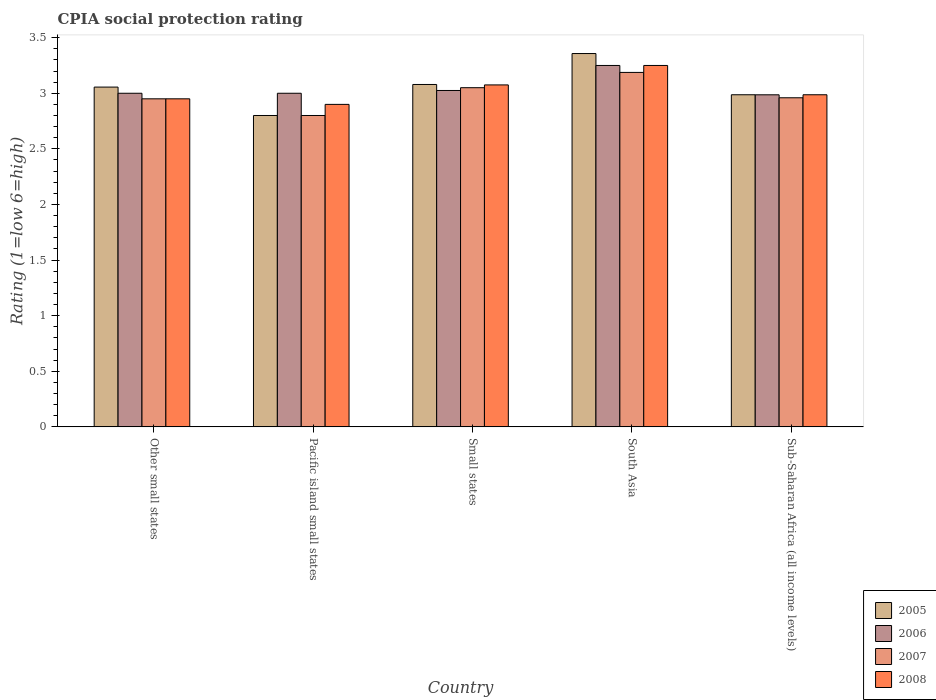How many groups of bars are there?
Your answer should be compact. 5. Are the number of bars per tick equal to the number of legend labels?
Your answer should be compact. Yes. How many bars are there on the 1st tick from the left?
Offer a very short reply. 4. How many bars are there on the 5th tick from the right?
Offer a terse response. 4. What is the label of the 4th group of bars from the left?
Provide a short and direct response. South Asia. What is the CPIA rating in 2005 in Sub-Saharan Africa (all income levels)?
Your answer should be compact. 2.99. Across all countries, what is the maximum CPIA rating in 2006?
Keep it short and to the point. 3.25. Across all countries, what is the minimum CPIA rating in 2006?
Provide a short and direct response. 2.99. In which country was the CPIA rating in 2007 maximum?
Offer a terse response. South Asia. In which country was the CPIA rating in 2008 minimum?
Your answer should be very brief. Pacific island small states. What is the total CPIA rating in 2007 in the graph?
Keep it short and to the point. 14.95. What is the difference between the CPIA rating in 2007 in Other small states and that in South Asia?
Provide a succinct answer. -0.24. What is the difference between the CPIA rating in 2006 in Sub-Saharan Africa (all income levels) and the CPIA rating in 2005 in Other small states?
Make the answer very short. -0.07. What is the average CPIA rating in 2005 per country?
Provide a succinct answer. 3.06. What is the difference between the CPIA rating of/in 2007 and CPIA rating of/in 2005 in South Asia?
Provide a short and direct response. -0.17. What is the ratio of the CPIA rating in 2008 in Other small states to that in Small states?
Your answer should be very brief. 0.96. What is the difference between the highest and the second highest CPIA rating in 2005?
Your answer should be compact. -0.28. What is the difference between the highest and the lowest CPIA rating in 2006?
Provide a succinct answer. 0.26. In how many countries, is the CPIA rating in 2006 greater than the average CPIA rating in 2006 taken over all countries?
Provide a succinct answer. 1. Is the sum of the CPIA rating in 2007 in Small states and South Asia greater than the maximum CPIA rating in 2005 across all countries?
Provide a short and direct response. Yes. Is it the case that in every country, the sum of the CPIA rating in 2005 and CPIA rating in 2008 is greater than the sum of CPIA rating in 2006 and CPIA rating in 2007?
Offer a terse response. No. What does the 3rd bar from the right in Small states represents?
Give a very brief answer. 2006. Are all the bars in the graph horizontal?
Make the answer very short. No. How many countries are there in the graph?
Ensure brevity in your answer.  5. What is the difference between two consecutive major ticks on the Y-axis?
Your answer should be very brief. 0.5. Does the graph contain any zero values?
Provide a succinct answer. No. Does the graph contain grids?
Provide a succinct answer. No. What is the title of the graph?
Your response must be concise. CPIA social protection rating. Does "1973" appear as one of the legend labels in the graph?
Provide a short and direct response. No. What is the label or title of the X-axis?
Ensure brevity in your answer.  Country. What is the Rating (1=low 6=high) of 2005 in Other small states?
Your response must be concise. 3.06. What is the Rating (1=low 6=high) of 2007 in Other small states?
Your answer should be very brief. 2.95. What is the Rating (1=low 6=high) in 2008 in Other small states?
Your response must be concise. 2.95. What is the Rating (1=low 6=high) in 2005 in Pacific island small states?
Give a very brief answer. 2.8. What is the Rating (1=low 6=high) of 2006 in Pacific island small states?
Ensure brevity in your answer.  3. What is the Rating (1=low 6=high) in 2008 in Pacific island small states?
Give a very brief answer. 2.9. What is the Rating (1=low 6=high) in 2005 in Small states?
Make the answer very short. 3.08. What is the Rating (1=low 6=high) in 2006 in Small states?
Make the answer very short. 3.02. What is the Rating (1=low 6=high) of 2007 in Small states?
Ensure brevity in your answer.  3.05. What is the Rating (1=low 6=high) of 2008 in Small states?
Provide a short and direct response. 3.08. What is the Rating (1=low 6=high) of 2005 in South Asia?
Provide a short and direct response. 3.36. What is the Rating (1=low 6=high) in 2006 in South Asia?
Your answer should be very brief. 3.25. What is the Rating (1=low 6=high) of 2007 in South Asia?
Make the answer very short. 3.19. What is the Rating (1=low 6=high) in 2008 in South Asia?
Offer a terse response. 3.25. What is the Rating (1=low 6=high) in 2005 in Sub-Saharan Africa (all income levels)?
Ensure brevity in your answer.  2.99. What is the Rating (1=low 6=high) in 2006 in Sub-Saharan Africa (all income levels)?
Offer a very short reply. 2.99. What is the Rating (1=low 6=high) in 2007 in Sub-Saharan Africa (all income levels)?
Your answer should be very brief. 2.96. What is the Rating (1=low 6=high) in 2008 in Sub-Saharan Africa (all income levels)?
Offer a terse response. 2.99. Across all countries, what is the maximum Rating (1=low 6=high) of 2005?
Your answer should be compact. 3.36. Across all countries, what is the maximum Rating (1=low 6=high) in 2006?
Your answer should be compact. 3.25. Across all countries, what is the maximum Rating (1=low 6=high) of 2007?
Keep it short and to the point. 3.19. Across all countries, what is the minimum Rating (1=low 6=high) of 2005?
Your response must be concise. 2.8. Across all countries, what is the minimum Rating (1=low 6=high) in 2006?
Your response must be concise. 2.99. Across all countries, what is the minimum Rating (1=low 6=high) in 2007?
Provide a short and direct response. 2.8. Across all countries, what is the minimum Rating (1=low 6=high) in 2008?
Your response must be concise. 2.9. What is the total Rating (1=low 6=high) of 2005 in the graph?
Give a very brief answer. 15.28. What is the total Rating (1=low 6=high) in 2006 in the graph?
Keep it short and to the point. 15.26. What is the total Rating (1=low 6=high) of 2007 in the graph?
Your answer should be very brief. 14.95. What is the total Rating (1=low 6=high) in 2008 in the graph?
Ensure brevity in your answer.  15.16. What is the difference between the Rating (1=low 6=high) in 2005 in Other small states and that in Pacific island small states?
Offer a very short reply. 0.26. What is the difference between the Rating (1=low 6=high) of 2007 in Other small states and that in Pacific island small states?
Give a very brief answer. 0.15. What is the difference between the Rating (1=low 6=high) of 2005 in Other small states and that in Small states?
Provide a succinct answer. -0.02. What is the difference between the Rating (1=low 6=high) in 2006 in Other small states and that in Small states?
Your answer should be compact. -0.03. What is the difference between the Rating (1=low 6=high) in 2008 in Other small states and that in Small states?
Offer a very short reply. -0.12. What is the difference between the Rating (1=low 6=high) in 2005 in Other small states and that in South Asia?
Your answer should be compact. -0.3. What is the difference between the Rating (1=low 6=high) of 2006 in Other small states and that in South Asia?
Keep it short and to the point. -0.25. What is the difference between the Rating (1=low 6=high) in 2007 in Other small states and that in South Asia?
Provide a succinct answer. -0.24. What is the difference between the Rating (1=low 6=high) of 2008 in Other small states and that in South Asia?
Give a very brief answer. -0.3. What is the difference between the Rating (1=low 6=high) of 2005 in Other small states and that in Sub-Saharan Africa (all income levels)?
Your answer should be very brief. 0.07. What is the difference between the Rating (1=low 6=high) in 2006 in Other small states and that in Sub-Saharan Africa (all income levels)?
Provide a succinct answer. 0.01. What is the difference between the Rating (1=low 6=high) of 2007 in Other small states and that in Sub-Saharan Africa (all income levels)?
Offer a very short reply. -0.01. What is the difference between the Rating (1=low 6=high) in 2008 in Other small states and that in Sub-Saharan Africa (all income levels)?
Your response must be concise. -0.04. What is the difference between the Rating (1=low 6=high) in 2005 in Pacific island small states and that in Small states?
Provide a short and direct response. -0.28. What is the difference between the Rating (1=low 6=high) of 2006 in Pacific island small states and that in Small states?
Offer a very short reply. -0.03. What is the difference between the Rating (1=low 6=high) of 2007 in Pacific island small states and that in Small states?
Offer a very short reply. -0.25. What is the difference between the Rating (1=low 6=high) in 2008 in Pacific island small states and that in Small states?
Your answer should be compact. -0.17. What is the difference between the Rating (1=low 6=high) in 2005 in Pacific island small states and that in South Asia?
Ensure brevity in your answer.  -0.56. What is the difference between the Rating (1=low 6=high) of 2007 in Pacific island small states and that in South Asia?
Offer a terse response. -0.39. What is the difference between the Rating (1=low 6=high) in 2008 in Pacific island small states and that in South Asia?
Keep it short and to the point. -0.35. What is the difference between the Rating (1=low 6=high) of 2005 in Pacific island small states and that in Sub-Saharan Africa (all income levels)?
Ensure brevity in your answer.  -0.19. What is the difference between the Rating (1=low 6=high) of 2006 in Pacific island small states and that in Sub-Saharan Africa (all income levels)?
Offer a terse response. 0.01. What is the difference between the Rating (1=low 6=high) of 2007 in Pacific island small states and that in Sub-Saharan Africa (all income levels)?
Ensure brevity in your answer.  -0.16. What is the difference between the Rating (1=low 6=high) of 2008 in Pacific island small states and that in Sub-Saharan Africa (all income levels)?
Keep it short and to the point. -0.09. What is the difference between the Rating (1=low 6=high) in 2005 in Small states and that in South Asia?
Offer a very short reply. -0.28. What is the difference between the Rating (1=low 6=high) in 2006 in Small states and that in South Asia?
Offer a very short reply. -0.23. What is the difference between the Rating (1=low 6=high) of 2007 in Small states and that in South Asia?
Your answer should be very brief. -0.14. What is the difference between the Rating (1=low 6=high) in 2008 in Small states and that in South Asia?
Your answer should be very brief. -0.17. What is the difference between the Rating (1=low 6=high) of 2005 in Small states and that in Sub-Saharan Africa (all income levels)?
Your answer should be compact. 0.09. What is the difference between the Rating (1=low 6=high) in 2006 in Small states and that in Sub-Saharan Africa (all income levels)?
Ensure brevity in your answer.  0.04. What is the difference between the Rating (1=low 6=high) of 2007 in Small states and that in Sub-Saharan Africa (all income levels)?
Offer a very short reply. 0.09. What is the difference between the Rating (1=low 6=high) of 2008 in Small states and that in Sub-Saharan Africa (all income levels)?
Provide a succinct answer. 0.09. What is the difference between the Rating (1=low 6=high) of 2005 in South Asia and that in Sub-Saharan Africa (all income levels)?
Keep it short and to the point. 0.37. What is the difference between the Rating (1=low 6=high) of 2006 in South Asia and that in Sub-Saharan Africa (all income levels)?
Make the answer very short. 0.26. What is the difference between the Rating (1=low 6=high) of 2007 in South Asia and that in Sub-Saharan Africa (all income levels)?
Offer a terse response. 0.23. What is the difference between the Rating (1=low 6=high) in 2008 in South Asia and that in Sub-Saharan Africa (all income levels)?
Keep it short and to the point. 0.26. What is the difference between the Rating (1=low 6=high) of 2005 in Other small states and the Rating (1=low 6=high) of 2006 in Pacific island small states?
Your answer should be very brief. 0.06. What is the difference between the Rating (1=low 6=high) in 2005 in Other small states and the Rating (1=low 6=high) in 2007 in Pacific island small states?
Make the answer very short. 0.26. What is the difference between the Rating (1=low 6=high) in 2005 in Other small states and the Rating (1=low 6=high) in 2008 in Pacific island small states?
Your answer should be very brief. 0.16. What is the difference between the Rating (1=low 6=high) of 2007 in Other small states and the Rating (1=low 6=high) of 2008 in Pacific island small states?
Provide a succinct answer. 0.05. What is the difference between the Rating (1=low 6=high) of 2005 in Other small states and the Rating (1=low 6=high) of 2006 in Small states?
Provide a succinct answer. 0.03. What is the difference between the Rating (1=low 6=high) in 2005 in Other small states and the Rating (1=low 6=high) in 2007 in Small states?
Your answer should be compact. 0.01. What is the difference between the Rating (1=low 6=high) in 2005 in Other small states and the Rating (1=low 6=high) in 2008 in Small states?
Offer a terse response. -0.02. What is the difference between the Rating (1=low 6=high) in 2006 in Other small states and the Rating (1=low 6=high) in 2008 in Small states?
Provide a succinct answer. -0.07. What is the difference between the Rating (1=low 6=high) of 2007 in Other small states and the Rating (1=low 6=high) of 2008 in Small states?
Your answer should be very brief. -0.12. What is the difference between the Rating (1=low 6=high) of 2005 in Other small states and the Rating (1=low 6=high) of 2006 in South Asia?
Provide a succinct answer. -0.19. What is the difference between the Rating (1=low 6=high) of 2005 in Other small states and the Rating (1=low 6=high) of 2007 in South Asia?
Provide a succinct answer. -0.13. What is the difference between the Rating (1=low 6=high) of 2005 in Other small states and the Rating (1=low 6=high) of 2008 in South Asia?
Provide a short and direct response. -0.19. What is the difference between the Rating (1=low 6=high) of 2006 in Other small states and the Rating (1=low 6=high) of 2007 in South Asia?
Offer a very short reply. -0.19. What is the difference between the Rating (1=low 6=high) of 2006 in Other small states and the Rating (1=low 6=high) of 2008 in South Asia?
Ensure brevity in your answer.  -0.25. What is the difference between the Rating (1=low 6=high) of 2005 in Other small states and the Rating (1=low 6=high) of 2006 in Sub-Saharan Africa (all income levels)?
Provide a succinct answer. 0.07. What is the difference between the Rating (1=low 6=high) of 2005 in Other small states and the Rating (1=low 6=high) of 2007 in Sub-Saharan Africa (all income levels)?
Give a very brief answer. 0.1. What is the difference between the Rating (1=low 6=high) of 2005 in Other small states and the Rating (1=low 6=high) of 2008 in Sub-Saharan Africa (all income levels)?
Your answer should be very brief. 0.07. What is the difference between the Rating (1=low 6=high) of 2006 in Other small states and the Rating (1=low 6=high) of 2007 in Sub-Saharan Africa (all income levels)?
Keep it short and to the point. 0.04. What is the difference between the Rating (1=low 6=high) in 2006 in Other small states and the Rating (1=low 6=high) in 2008 in Sub-Saharan Africa (all income levels)?
Give a very brief answer. 0.01. What is the difference between the Rating (1=low 6=high) in 2007 in Other small states and the Rating (1=low 6=high) in 2008 in Sub-Saharan Africa (all income levels)?
Give a very brief answer. -0.04. What is the difference between the Rating (1=low 6=high) in 2005 in Pacific island small states and the Rating (1=low 6=high) in 2006 in Small states?
Give a very brief answer. -0.23. What is the difference between the Rating (1=low 6=high) of 2005 in Pacific island small states and the Rating (1=low 6=high) of 2008 in Small states?
Your response must be concise. -0.28. What is the difference between the Rating (1=low 6=high) in 2006 in Pacific island small states and the Rating (1=low 6=high) in 2008 in Small states?
Give a very brief answer. -0.07. What is the difference between the Rating (1=low 6=high) in 2007 in Pacific island small states and the Rating (1=low 6=high) in 2008 in Small states?
Offer a terse response. -0.28. What is the difference between the Rating (1=low 6=high) of 2005 in Pacific island small states and the Rating (1=low 6=high) of 2006 in South Asia?
Offer a terse response. -0.45. What is the difference between the Rating (1=low 6=high) in 2005 in Pacific island small states and the Rating (1=low 6=high) in 2007 in South Asia?
Provide a succinct answer. -0.39. What is the difference between the Rating (1=low 6=high) of 2005 in Pacific island small states and the Rating (1=low 6=high) of 2008 in South Asia?
Your answer should be compact. -0.45. What is the difference between the Rating (1=low 6=high) of 2006 in Pacific island small states and the Rating (1=low 6=high) of 2007 in South Asia?
Your answer should be very brief. -0.19. What is the difference between the Rating (1=low 6=high) of 2006 in Pacific island small states and the Rating (1=low 6=high) of 2008 in South Asia?
Give a very brief answer. -0.25. What is the difference between the Rating (1=low 6=high) of 2007 in Pacific island small states and the Rating (1=low 6=high) of 2008 in South Asia?
Your response must be concise. -0.45. What is the difference between the Rating (1=low 6=high) of 2005 in Pacific island small states and the Rating (1=low 6=high) of 2006 in Sub-Saharan Africa (all income levels)?
Make the answer very short. -0.19. What is the difference between the Rating (1=low 6=high) of 2005 in Pacific island small states and the Rating (1=low 6=high) of 2007 in Sub-Saharan Africa (all income levels)?
Keep it short and to the point. -0.16. What is the difference between the Rating (1=low 6=high) of 2005 in Pacific island small states and the Rating (1=low 6=high) of 2008 in Sub-Saharan Africa (all income levels)?
Ensure brevity in your answer.  -0.19. What is the difference between the Rating (1=low 6=high) in 2006 in Pacific island small states and the Rating (1=low 6=high) in 2007 in Sub-Saharan Africa (all income levels)?
Your answer should be compact. 0.04. What is the difference between the Rating (1=low 6=high) in 2006 in Pacific island small states and the Rating (1=low 6=high) in 2008 in Sub-Saharan Africa (all income levels)?
Your answer should be compact. 0.01. What is the difference between the Rating (1=low 6=high) of 2007 in Pacific island small states and the Rating (1=low 6=high) of 2008 in Sub-Saharan Africa (all income levels)?
Your answer should be compact. -0.19. What is the difference between the Rating (1=low 6=high) of 2005 in Small states and the Rating (1=low 6=high) of 2006 in South Asia?
Your response must be concise. -0.17. What is the difference between the Rating (1=low 6=high) of 2005 in Small states and the Rating (1=low 6=high) of 2007 in South Asia?
Your answer should be very brief. -0.11. What is the difference between the Rating (1=low 6=high) of 2005 in Small states and the Rating (1=low 6=high) of 2008 in South Asia?
Make the answer very short. -0.17. What is the difference between the Rating (1=low 6=high) in 2006 in Small states and the Rating (1=low 6=high) in 2007 in South Asia?
Your answer should be very brief. -0.16. What is the difference between the Rating (1=low 6=high) of 2006 in Small states and the Rating (1=low 6=high) of 2008 in South Asia?
Offer a very short reply. -0.23. What is the difference between the Rating (1=low 6=high) of 2005 in Small states and the Rating (1=low 6=high) of 2006 in Sub-Saharan Africa (all income levels)?
Your response must be concise. 0.09. What is the difference between the Rating (1=low 6=high) in 2005 in Small states and the Rating (1=low 6=high) in 2007 in Sub-Saharan Africa (all income levels)?
Provide a short and direct response. 0.12. What is the difference between the Rating (1=low 6=high) in 2005 in Small states and the Rating (1=low 6=high) in 2008 in Sub-Saharan Africa (all income levels)?
Your answer should be compact. 0.09. What is the difference between the Rating (1=low 6=high) of 2006 in Small states and the Rating (1=low 6=high) of 2007 in Sub-Saharan Africa (all income levels)?
Your answer should be very brief. 0.07. What is the difference between the Rating (1=low 6=high) in 2006 in Small states and the Rating (1=low 6=high) in 2008 in Sub-Saharan Africa (all income levels)?
Ensure brevity in your answer.  0.04. What is the difference between the Rating (1=low 6=high) of 2007 in Small states and the Rating (1=low 6=high) of 2008 in Sub-Saharan Africa (all income levels)?
Provide a succinct answer. 0.06. What is the difference between the Rating (1=low 6=high) of 2005 in South Asia and the Rating (1=low 6=high) of 2006 in Sub-Saharan Africa (all income levels)?
Give a very brief answer. 0.37. What is the difference between the Rating (1=low 6=high) of 2005 in South Asia and the Rating (1=low 6=high) of 2007 in Sub-Saharan Africa (all income levels)?
Provide a succinct answer. 0.4. What is the difference between the Rating (1=low 6=high) in 2005 in South Asia and the Rating (1=low 6=high) in 2008 in Sub-Saharan Africa (all income levels)?
Offer a terse response. 0.37. What is the difference between the Rating (1=low 6=high) of 2006 in South Asia and the Rating (1=low 6=high) of 2007 in Sub-Saharan Africa (all income levels)?
Provide a succinct answer. 0.29. What is the difference between the Rating (1=low 6=high) of 2006 in South Asia and the Rating (1=low 6=high) of 2008 in Sub-Saharan Africa (all income levels)?
Offer a terse response. 0.26. What is the difference between the Rating (1=low 6=high) in 2007 in South Asia and the Rating (1=low 6=high) in 2008 in Sub-Saharan Africa (all income levels)?
Your answer should be compact. 0.2. What is the average Rating (1=low 6=high) in 2005 per country?
Provide a succinct answer. 3.06. What is the average Rating (1=low 6=high) of 2006 per country?
Give a very brief answer. 3.05. What is the average Rating (1=low 6=high) of 2007 per country?
Ensure brevity in your answer.  2.99. What is the average Rating (1=low 6=high) in 2008 per country?
Provide a succinct answer. 3.03. What is the difference between the Rating (1=low 6=high) in 2005 and Rating (1=low 6=high) in 2006 in Other small states?
Your answer should be compact. 0.06. What is the difference between the Rating (1=low 6=high) in 2005 and Rating (1=low 6=high) in 2007 in Other small states?
Provide a succinct answer. 0.11. What is the difference between the Rating (1=low 6=high) in 2005 and Rating (1=low 6=high) in 2008 in Other small states?
Provide a succinct answer. 0.11. What is the difference between the Rating (1=low 6=high) in 2006 and Rating (1=low 6=high) in 2007 in Other small states?
Offer a very short reply. 0.05. What is the difference between the Rating (1=low 6=high) in 2005 and Rating (1=low 6=high) in 2006 in Pacific island small states?
Your response must be concise. -0.2. What is the difference between the Rating (1=low 6=high) in 2005 and Rating (1=low 6=high) in 2007 in Pacific island small states?
Ensure brevity in your answer.  0. What is the difference between the Rating (1=low 6=high) of 2005 and Rating (1=low 6=high) of 2006 in Small states?
Offer a very short reply. 0.05. What is the difference between the Rating (1=low 6=high) in 2005 and Rating (1=low 6=high) in 2007 in Small states?
Provide a short and direct response. 0.03. What is the difference between the Rating (1=low 6=high) in 2005 and Rating (1=low 6=high) in 2008 in Small states?
Your answer should be very brief. 0. What is the difference between the Rating (1=low 6=high) of 2006 and Rating (1=low 6=high) of 2007 in Small states?
Your answer should be very brief. -0.03. What is the difference between the Rating (1=low 6=high) of 2006 and Rating (1=low 6=high) of 2008 in Small states?
Provide a succinct answer. -0.05. What is the difference between the Rating (1=low 6=high) of 2007 and Rating (1=low 6=high) of 2008 in Small states?
Provide a succinct answer. -0.03. What is the difference between the Rating (1=low 6=high) of 2005 and Rating (1=low 6=high) of 2006 in South Asia?
Your response must be concise. 0.11. What is the difference between the Rating (1=low 6=high) in 2005 and Rating (1=low 6=high) in 2007 in South Asia?
Your answer should be compact. 0.17. What is the difference between the Rating (1=low 6=high) of 2005 and Rating (1=low 6=high) of 2008 in South Asia?
Offer a terse response. 0.11. What is the difference between the Rating (1=low 6=high) of 2006 and Rating (1=low 6=high) of 2007 in South Asia?
Offer a terse response. 0.06. What is the difference between the Rating (1=low 6=high) of 2007 and Rating (1=low 6=high) of 2008 in South Asia?
Give a very brief answer. -0.06. What is the difference between the Rating (1=low 6=high) in 2005 and Rating (1=low 6=high) in 2007 in Sub-Saharan Africa (all income levels)?
Offer a very short reply. 0.03. What is the difference between the Rating (1=low 6=high) in 2005 and Rating (1=low 6=high) in 2008 in Sub-Saharan Africa (all income levels)?
Keep it short and to the point. 0. What is the difference between the Rating (1=low 6=high) in 2006 and Rating (1=low 6=high) in 2007 in Sub-Saharan Africa (all income levels)?
Your answer should be compact. 0.03. What is the difference between the Rating (1=low 6=high) in 2006 and Rating (1=low 6=high) in 2008 in Sub-Saharan Africa (all income levels)?
Keep it short and to the point. -0. What is the difference between the Rating (1=low 6=high) of 2007 and Rating (1=low 6=high) of 2008 in Sub-Saharan Africa (all income levels)?
Provide a succinct answer. -0.03. What is the ratio of the Rating (1=low 6=high) of 2005 in Other small states to that in Pacific island small states?
Provide a succinct answer. 1.09. What is the ratio of the Rating (1=low 6=high) in 2006 in Other small states to that in Pacific island small states?
Keep it short and to the point. 1. What is the ratio of the Rating (1=low 6=high) of 2007 in Other small states to that in Pacific island small states?
Provide a short and direct response. 1.05. What is the ratio of the Rating (1=low 6=high) in 2008 in Other small states to that in Pacific island small states?
Offer a very short reply. 1.02. What is the ratio of the Rating (1=low 6=high) of 2005 in Other small states to that in Small states?
Keep it short and to the point. 0.99. What is the ratio of the Rating (1=low 6=high) of 2006 in Other small states to that in Small states?
Your response must be concise. 0.99. What is the ratio of the Rating (1=low 6=high) in 2007 in Other small states to that in Small states?
Offer a terse response. 0.97. What is the ratio of the Rating (1=low 6=high) of 2008 in Other small states to that in Small states?
Your answer should be compact. 0.96. What is the ratio of the Rating (1=low 6=high) in 2005 in Other small states to that in South Asia?
Provide a short and direct response. 0.91. What is the ratio of the Rating (1=low 6=high) of 2006 in Other small states to that in South Asia?
Your response must be concise. 0.92. What is the ratio of the Rating (1=low 6=high) of 2007 in Other small states to that in South Asia?
Your answer should be compact. 0.93. What is the ratio of the Rating (1=low 6=high) in 2008 in Other small states to that in South Asia?
Your answer should be compact. 0.91. What is the ratio of the Rating (1=low 6=high) in 2005 in Other small states to that in Sub-Saharan Africa (all income levels)?
Your answer should be compact. 1.02. What is the ratio of the Rating (1=low 6=high) of 2006 in Other small states to that in Sub-Saharan Africa (all income levels)?
Ensure brevity in your answer.  1. What is the ratio of the Rating (1=low 6=high) in 2005 in Pacific island small states to that in Small states?
Ensure brevity in your answer.  0.91. What is the ratio of the Rating (1=low 6=high) of 2007 in Pacific island small states to that in Small states?
Ensure brevity in your answer.  0.92. What is the ratio of the Rating (1=low 6=high) of 2008 in Pacific island small states to that in Small states?
Provide a succinct answer. 0.94. What is the ratio of the Rating (1=low 6=high) of 2005 in Pacific island small states to that in South Asia?
Your response must be concise. 0.83. What is the ratio of the Rating (1=low 6=high) in 2006 in Pacific island small states to that in South Asia?
Make the answer very short. 0.92. What is the ratio of the Rating (1=low 6=high) of 2007 in Pacific island small states to that in South Asia?
Your answer should be very brief. 0.88. What is the ratio of the Rating (1=low 6=high) of 2008 in Pacific island small states to that in South Asia?
Offer a terse response. 0.89. What is the ratio of the Rating (1=low 6=high) in 2005 in Pacific island small states to that in Sub-Saharan Africa (all income levels)?
Offer a very short reply. 0.94. What is the ratio of the Rating (1=low 6=high) of 2006 in Pacific island small states to that in Sub-Saharan Africa (all income levels)?
Ensure brevity in your answer.  1. What is the ratio of the Rating (1=low 6=high) of 2007 in Pacific island small states to that in Sub-Saharan Africa (all income levels)?
Your answer should be compact. 0.95. What is the ratio of the Rating (1=low 6=high) in 2008 in Pacific island small states to that in Sub-Saharan Africa (all income levels)?
Your answer should be compact. 0.97. What is the ratio of the Rating (1=low 6=high) of 2005 in Small states to that in South Asia?
Keep it short and to the point. 0.92. What is the ratio of the Rating (1=low 6=high) of 2006 in Small states to that in South Asia?
Keep it short and to the point. 0.93. What is the ratio of the Rating (1=low 6=high) of 2007 in Small states to that in South Asia?
Ensure brevity in your answer.  0.96. What is the ratio of the Rating (1=low 6=high) in 2008 in Small states to that in South Asia?
Ensure brevity in your answer.  0.95. What is the ratio of the Rating (1=low 6=high) in 2005 in Small states to that in Sub-Saharan Africa (all income levels)?
Offer a very short reply. 1.03. What is the ratio of the Rating (1=low 6=high) in 2007 in Small states to that in Sub-Saharan Africa (all income levels)?
Ensure brevity in your answer.  1.03. What is the ratio of the Rating (1=low 6=high) in 2008 in Small states to that in Sub-Saharan Africa (all income levels)?
Keep it short and to the point. 1.03. What is the ratio of the Rating (1=low 6=high) in 2005 in South Asia to that in Sub-Saharan Africa (all income levels)?
Ensure brevity in your answer.  1.12. What is the ratio of the Rating (1=low 6=high) in 2006 in South Asia to that in Sub-Saharan Africa (all income levels)?
Ensure brevity in your answer.  1.09. What is the ratio of the Rating (1=low 6=high) of 2007 in South Asia to that in Sub-Saharan Africa (all income levels)?
Ensure brevity in your answer.  1.08. What is the ratio of the Rating (1=low 6=high) in 2008 in South Asia to that in Sub-Saharan Africa (all income levels)?
Provide a short and direct response. 1.09. What is the difference between the highest and the second highest Rating (1=low 6=high) in 2005?
Keep it short and to the point. 0.28. What is the difference between the highest and the second highest Rating (1=low 6=high) of 2006?
Ensure brevity in your answer.  0.23. What is the difference between the highest and the second highest Rating (1=low 6=high) of 2007?
Offer a terse response. 0.14. What is the difference between the highest and the second highest Rating (1=low 6=high) in 2008?
Provide a succinct answer. 0.17. What is the difference between the highest and the lowest Rating (1=low 6=high) in 2005?
Your response must be concise. 0.56. What is the difference between the highest and the lowest Rating (1=low 6=high) in 2006?
Provide a short and direct response. 0.26. What is the difference between the highest and the lowest Rating (1=low 6=high) in 2007?
Offer a very short reply. 0.39. 